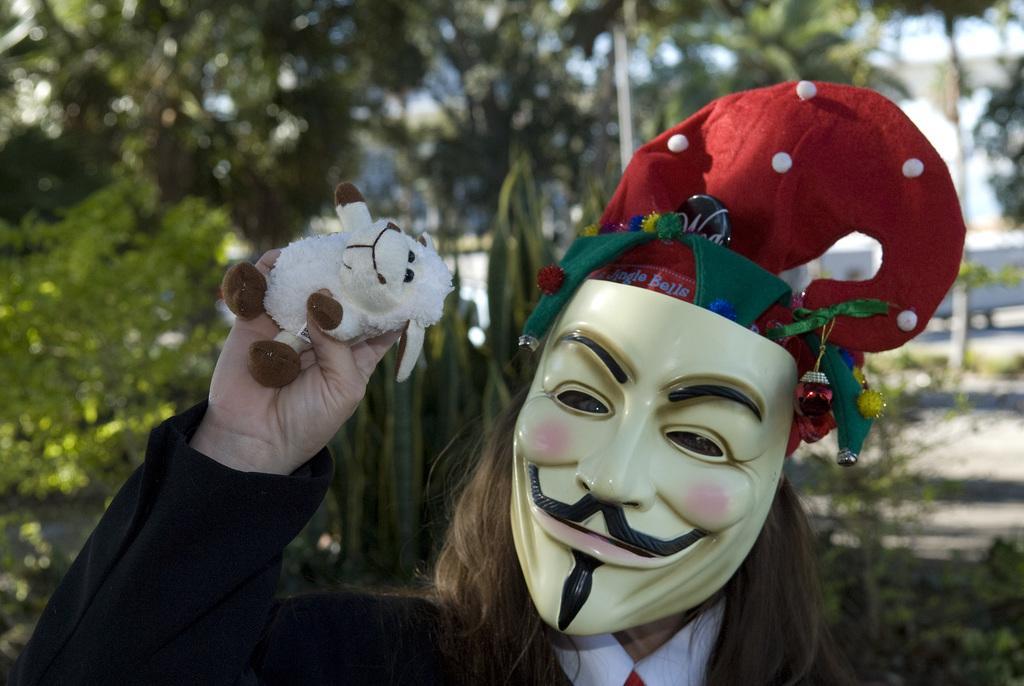Could you give a brief overview of what you see in this image? In this picture we can see a person wearing a mask and holding a toy in his hand. We can see a few trees in the background. 